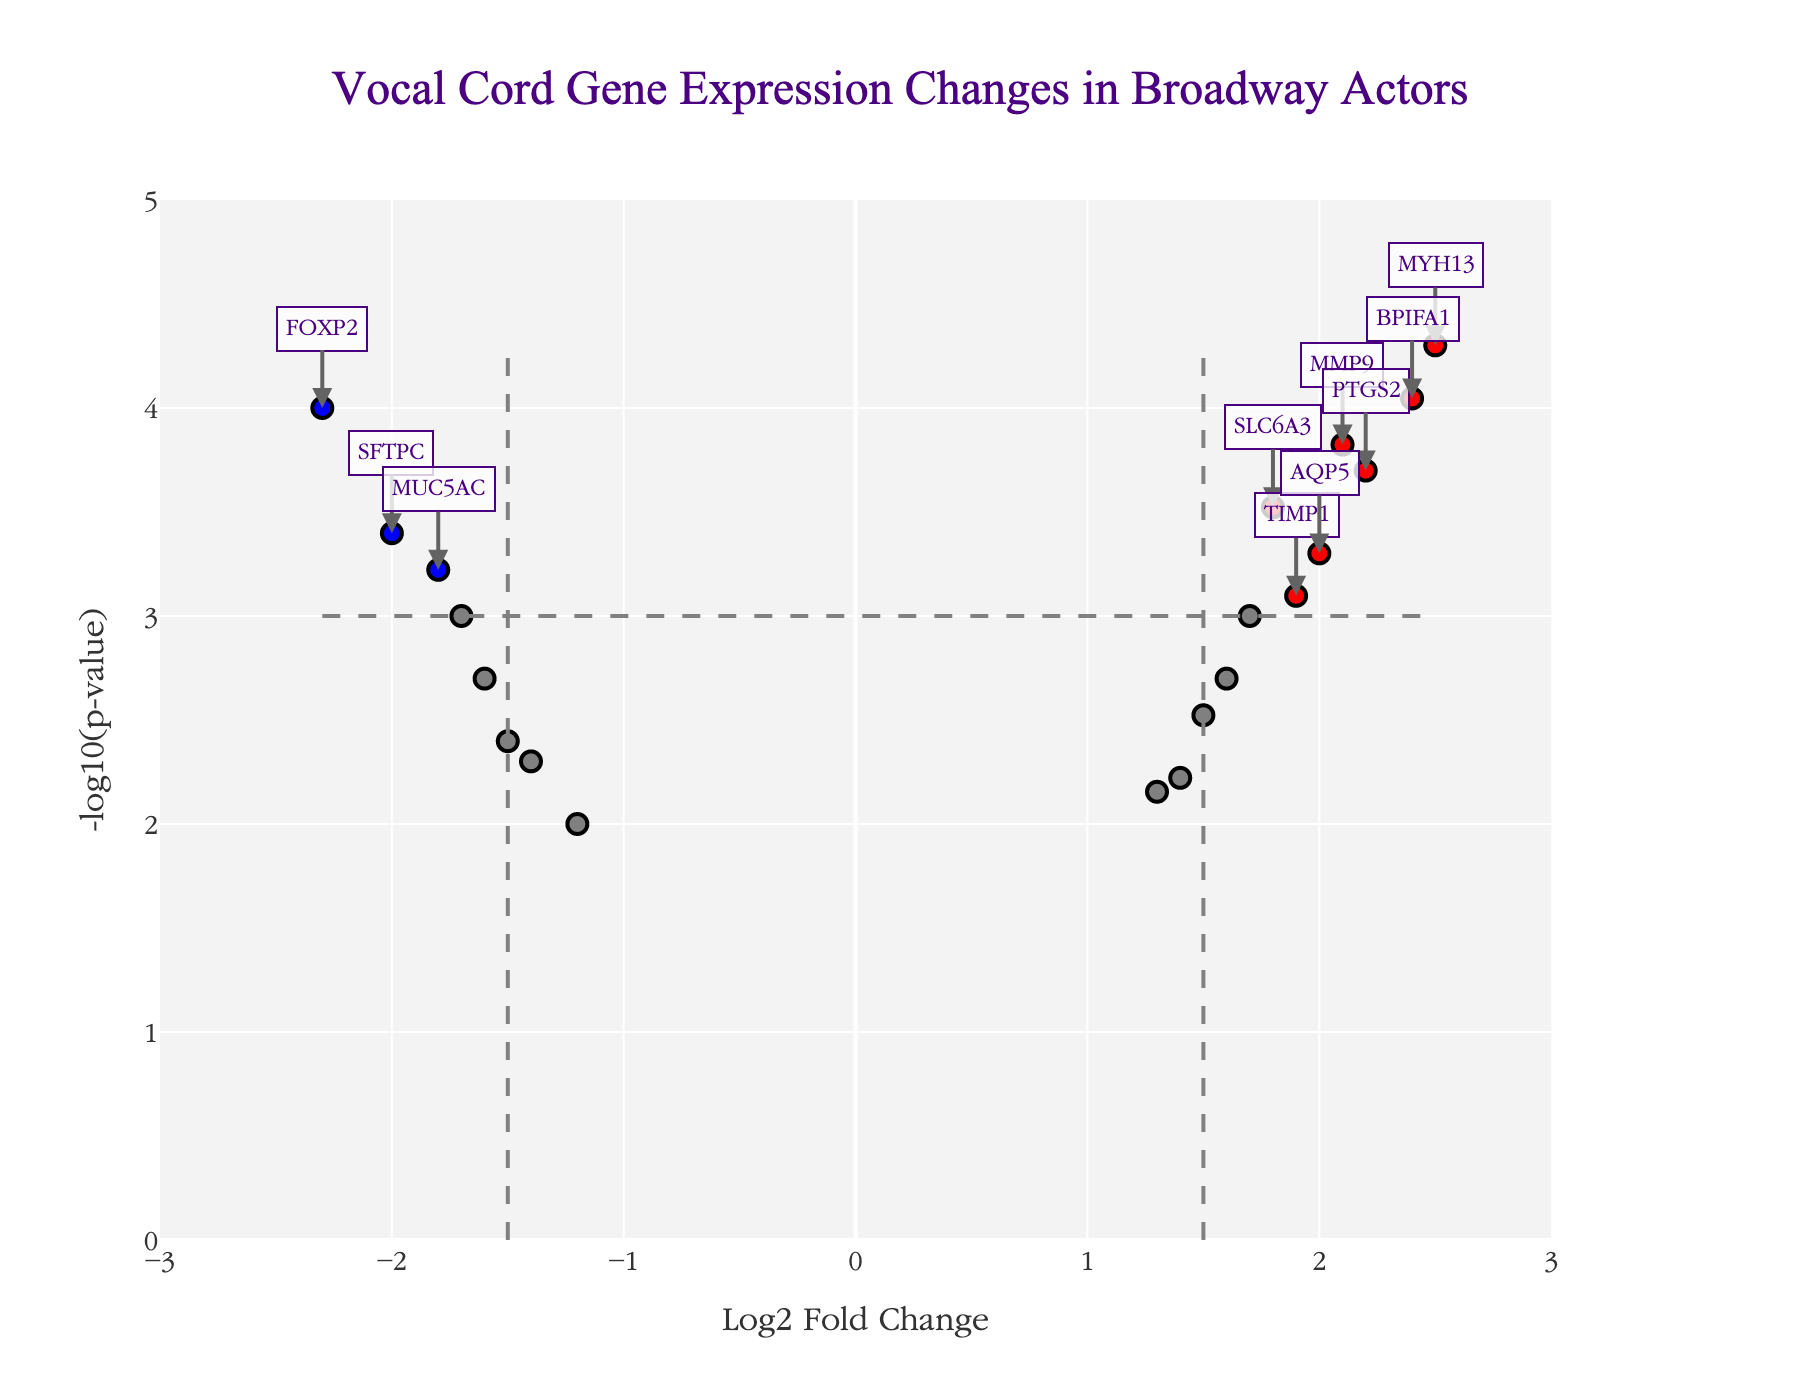How many genes are significantly up-regulated? Genes that are significantly up-regulated are highlighted in red and have a log2 fold change greater than 1.5 and a p-value less than 0.001. By counting such data points, we find there are 7.
Answer: 7 Which gene has the highest log2 fold change? By looking at the x-axis values, the gene with the highest log2 fold change is MYH13, as its point is farthest to the right.
Answer: MYH13 What is the log2 fold change for the significantly down-regulated gene with the smallest -log10(p-value)? The significantly down-regulated genes are those in blue. The one with the smallest -log10(p-value) will have the lowest y-value among this group. MUC5AC has the smallest -log10(p-value) among the significantly down-regulated genes. Its log2 fold change is -1.8.
Answer: -1.8 How many genes have a p-value lower than 0.001? To find the number of genes with a p-value lower than 0.001, count all data points with a -log10(p-value) greater than 3. There are 10 such genes.
Answer: 10 Which gene among the down-regulated ones has the highest p-value? Among the blue points representing down-regulated genes, the one closest to the x-axis (having the smallest -log10(p-value)) represents the highest p-value. This is VEGFA with a -log10(p-value) of 2, corresponding to a p-value of 0.01.
Answer: VEGFA What is the title of the plot? The title is clearly displayed at the top of the plot. It is "Vocal Cord Gene Expression Changes in Broadway Actors".
Answer: Vocal Cord Gene Expression Changes in Broadway Actors Compare the -log10(p-value) values of MYH13 and FOXP2. Which one is higher? By examining the y-axis values, you can compare the heights of the points corresponding to MYH13 and FOXP2. MYH13 is significantly higher.
Answer: MYH13 What is the range of the x-axis? The x-axis range can be observed by looking at the values from the leftmost to the rightmost part of the plot, which is from -3 to 3.
Answer: -3 to 3 What color category does IL6 fall into based on its log2 fold change and p-value? IL6 has a log2 fold change of 1.7 and a p-value of 0.001. Given its log2 fold change > 1.5 and p-value < 0.001, it falls into the up-regulated category, which is colored red.
Answer: red 